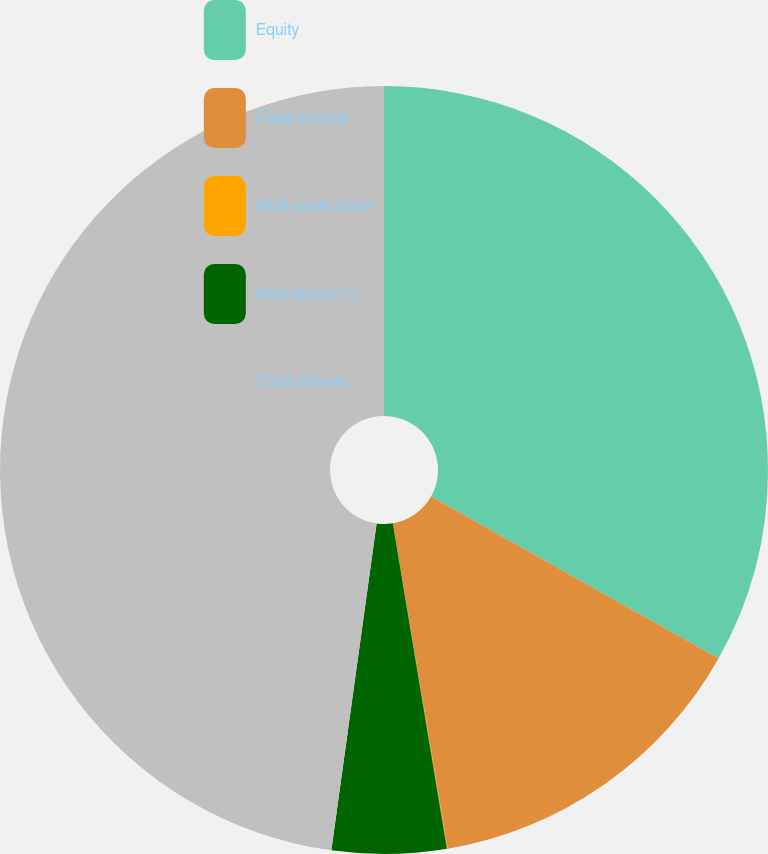<chart> <loc_0><loc_0><loc_500><loc_500><pie_chart><fcel>Equity<fcel>Fixed income<fcel>Multi-asset class<fcel>Alternatives (1)<fcel>Total iShares<nl><fcel>33.17%<fcel>14.18%<fcel>0.03%<fcel>4.81%<fcel>47.81%<nl></chart> 